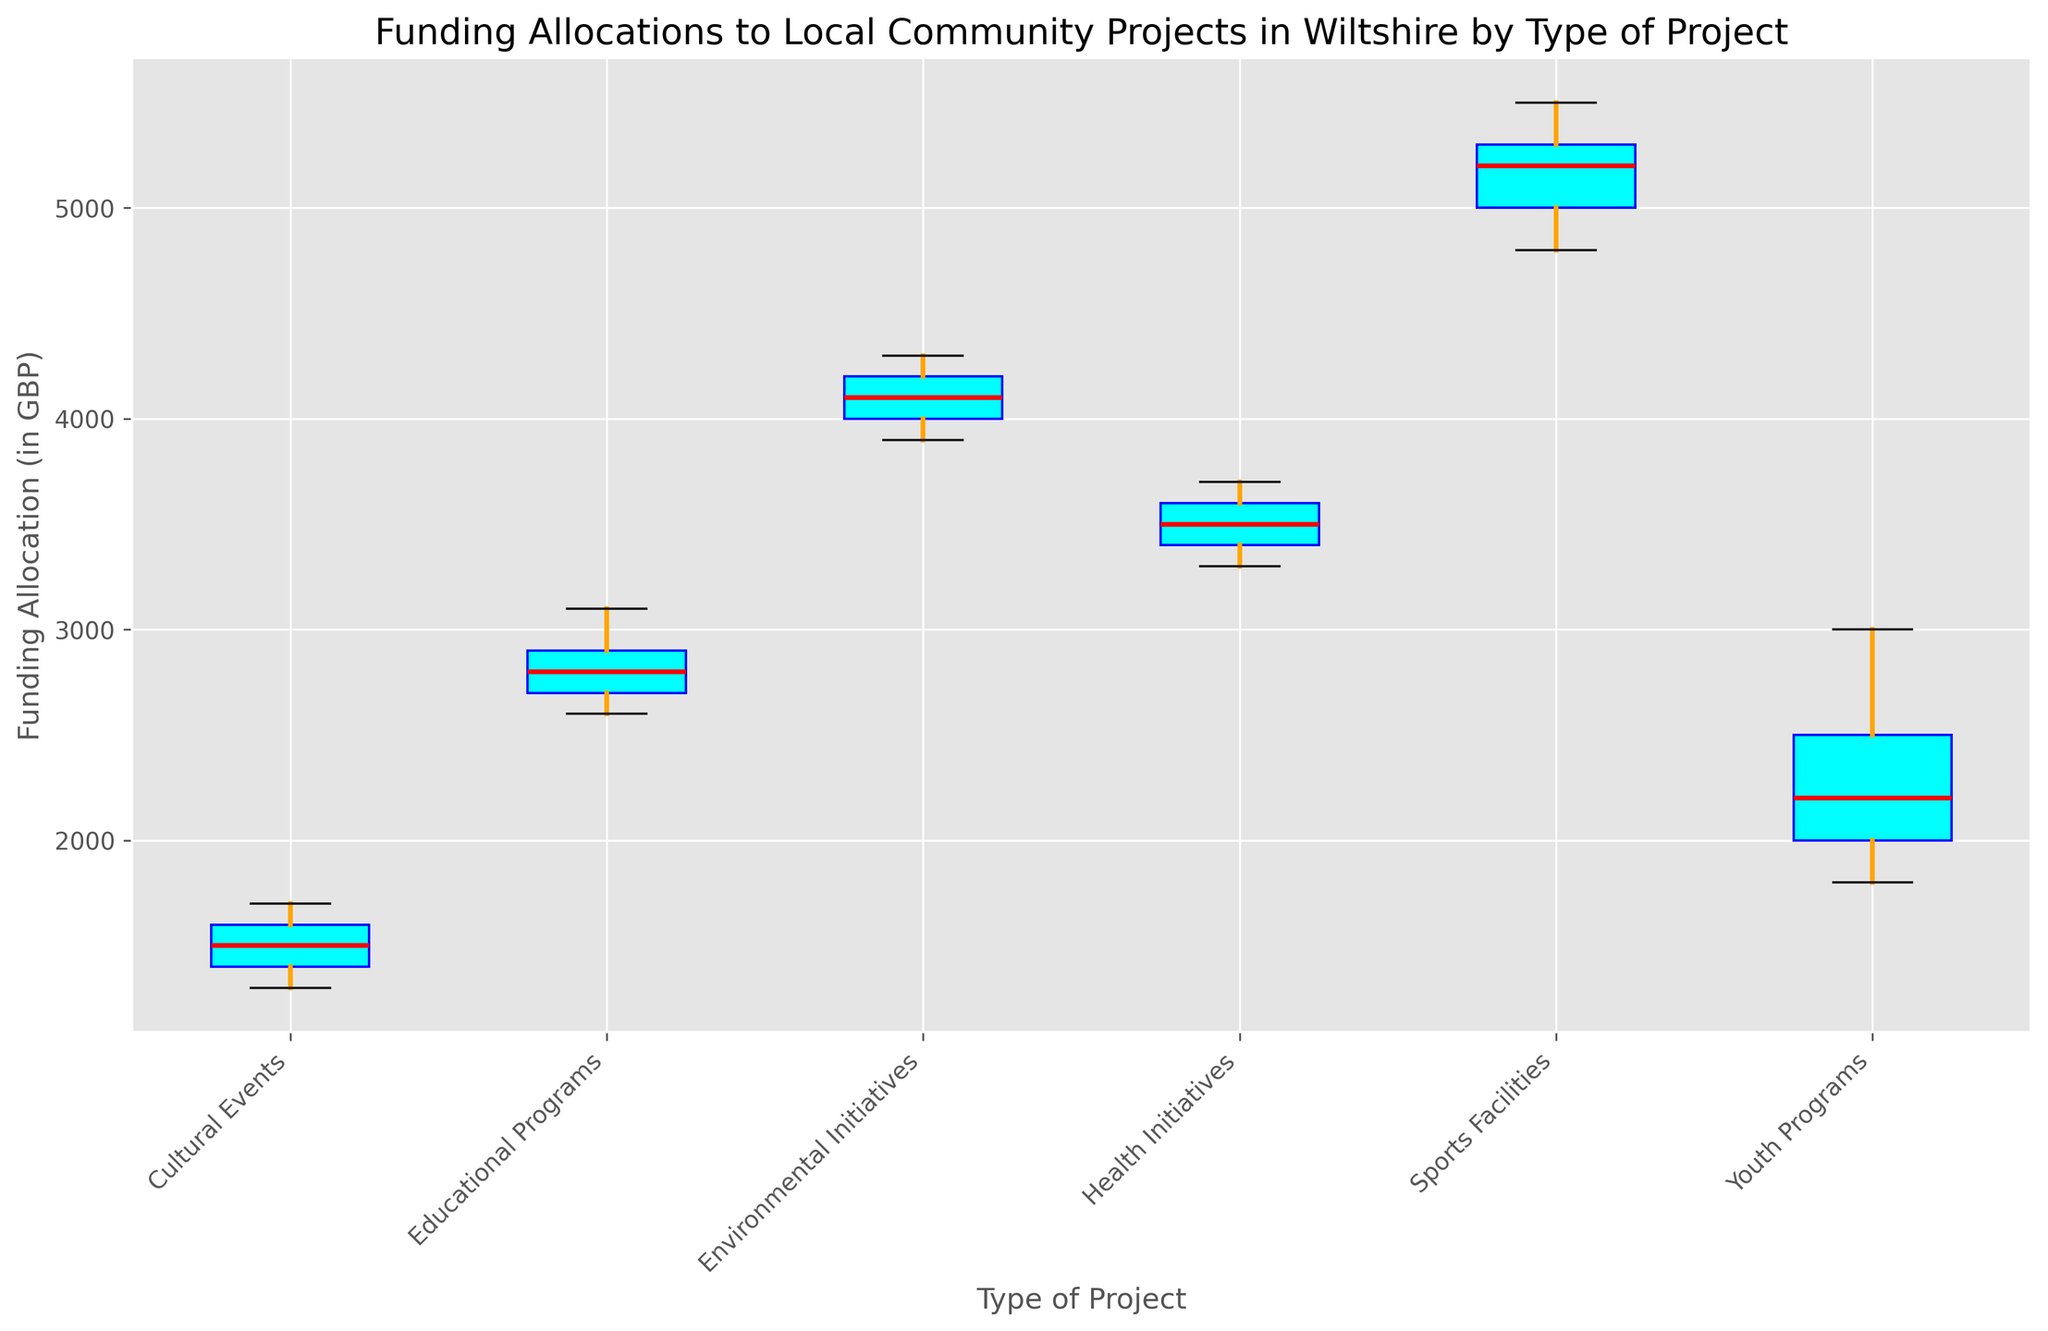What is the median funding allocation for Sports Facilities? The red line inside the Sports Facilities box indicates the median funding allocation.
Answer: 5200 GBP Which type of project received the highest maximum funding allocation? Look at the whiskers extending from the boxes; the Sports Facilities box has the highest whisker at around 5500 GBP.
Answer: Sports Facilities How does the median funding allocation for Youth Programs compare to Health Initiatives? The red line inside the Youth Programs box is at 2200 GBP, while the red line inside the Health Initiatives box is at 3500 GBP.
Answer: Health Initiatives has a higher median What is the range of funding allocations for Cultural Events? The range is determined by the distance from the smallest value (bottom whisker) to the largest value (top whisker) for Cultural Events. The smallest is 1300 GBP and the largest is 1700 GBP.
Answer: 400 GBP Which type of project has the widest interquartile range (IQR) for funding allocations? The IQR is the difference between the upper quartile (top of the box) and the lower quartile (bottom of the box). Inspect the height of the boxes. Sports Facilities have the widest box, indicating the largest IQR.
Answer: Sports Facilities What is the difference between the median funding allocation of Environmental Initiatives and Educational Programs? The median for Environmental Initiatives is 4100 GBP and for Educational Programs is 2800 GBP. The difference is 4100 - 2800.
Answer: 1300 GBP Do any of the project types have outliers? If so, which one/ones? Outliers are represented as individual points outside the whiskers. Inspect each box plot for such points.
Answer: No outliers What is the average maximum funding allocation across all project types? The maximum for each type can be seen at the top whisker positions: Youth Programs - 3000, Sports Facilities - 5500, Environmental Initiatives - 4300, Cultural Events - 1700, Health Initiatives - 3700, Educational Programs - 3100. The average is (3000 + 5500 + 4300 + 1700 + 3700 + 3100)/6.
Answer: 3550 GBP Which type of project has the most consistent (least variable) funding allocation? The smallest IQR indicates the most consistency. Cultural Events have the smallest IQR among all types.
Answer: Cultural Events 